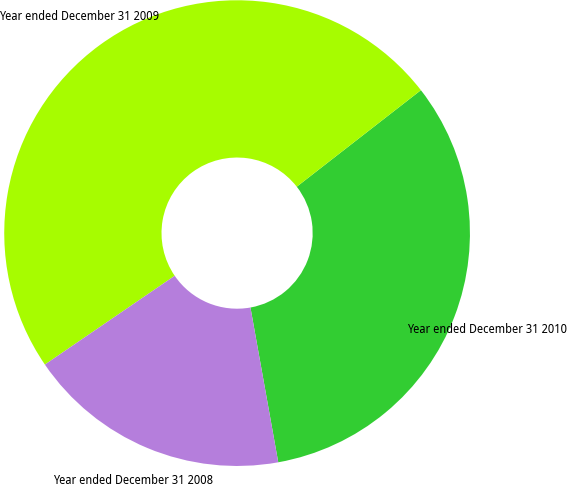<chart> <loc_0><loc_0><loc_500><loc_500><pie_chart><fcel>Year ended December 31 2010<fcel>Year ended December 31 2009<fcel>Year ended December 31 2008<nl><fcel>32.69%<fcel>49.03%<fcel>18.28%<nl></chart> 